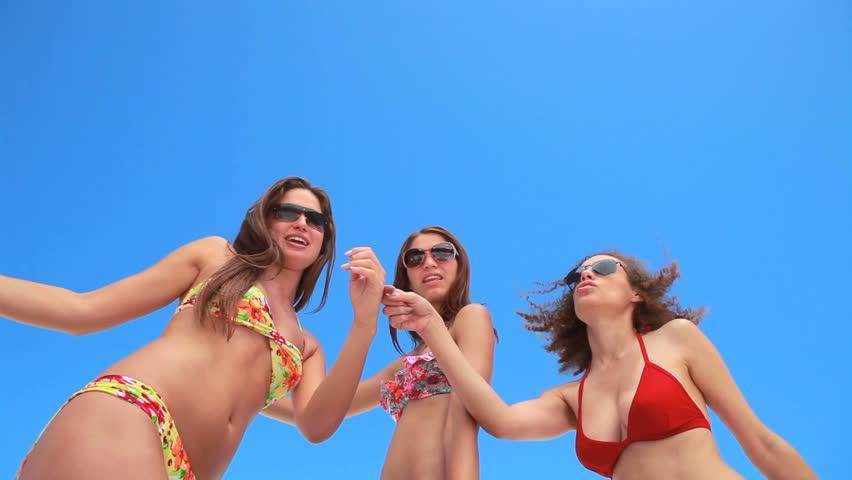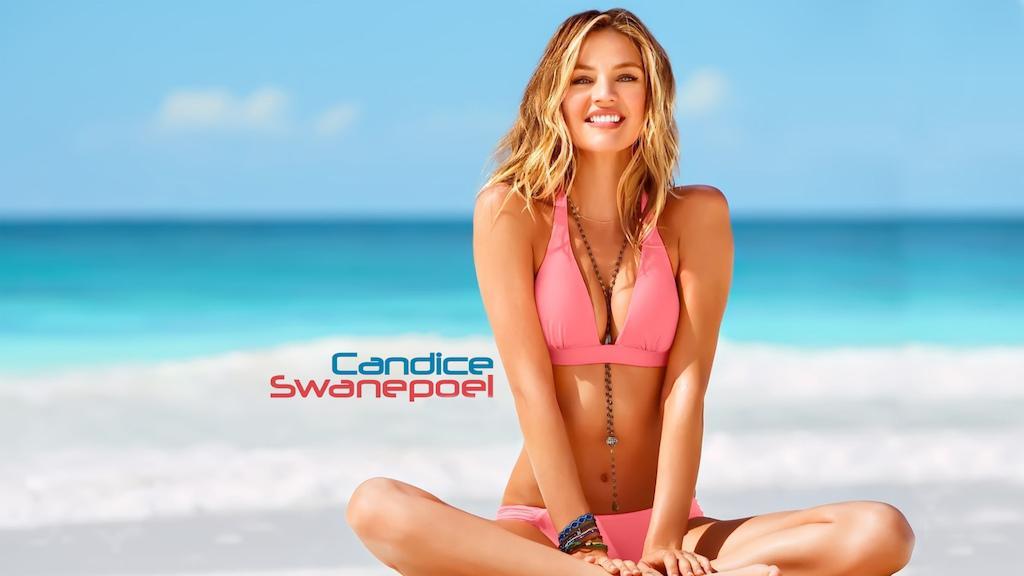The first image is the image on the left, the second image is the image on the right. Considering the images on both sides, is "There is a female wearing a pink bikini in the right image." valid? Answer yes or no. Yes. The first image is the image on the left, the second image is the image on the right. Examine the images to the left and right. Is the description "One of the images shows exactly one woman sitting at the beach wearing a bikini." accurate? Answer yes or no. Yes. 